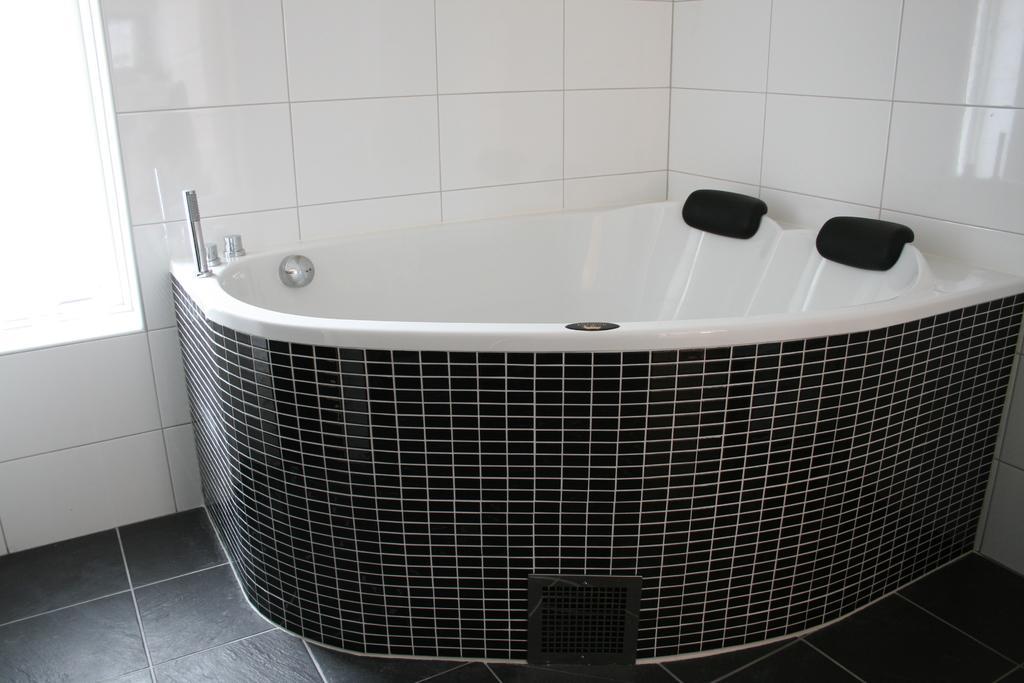Please provide a concise description of this image. In this image there is a bathing tube, in the background there is a wall. 